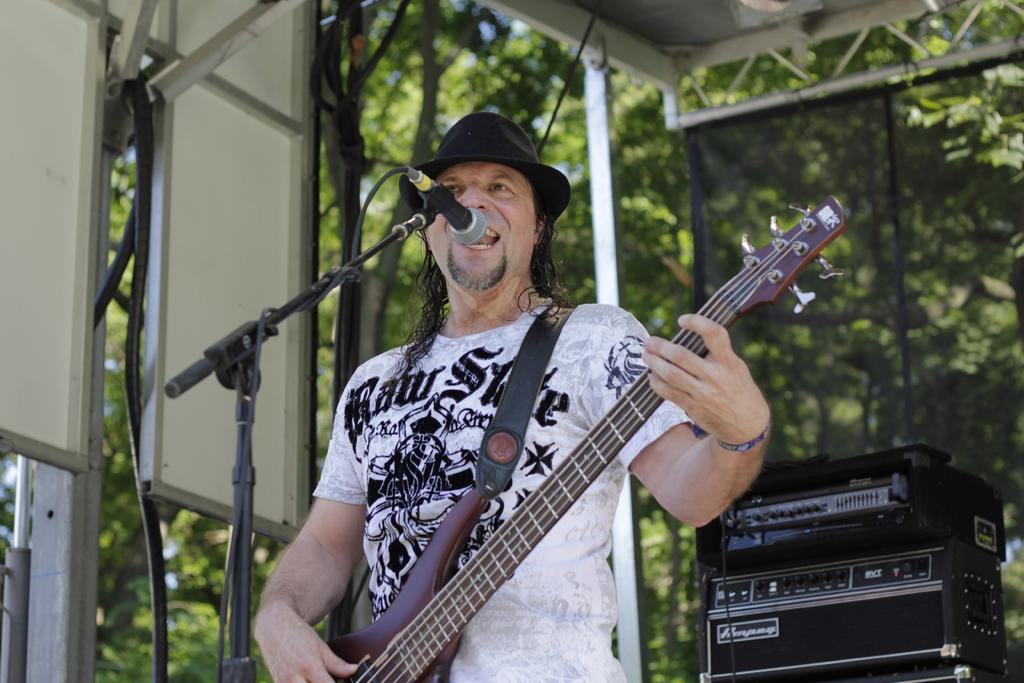What is the main subject of the image? The main subject of the image is a man. What is the man doing in the image? The man is standing and holding a guitar. What equipment is present in the image related to music? There is a microphone and a microphone stand in the image. What can be seen in the background of the image? Trees are visible in the background of the image. What type of writing can be seen on the guitar in the image? There is no visible writing on the guitar in the image. How does the man look at the trees in the background? The image does not show the man looking at the trees; it only shows him standing and holding a guitar. 